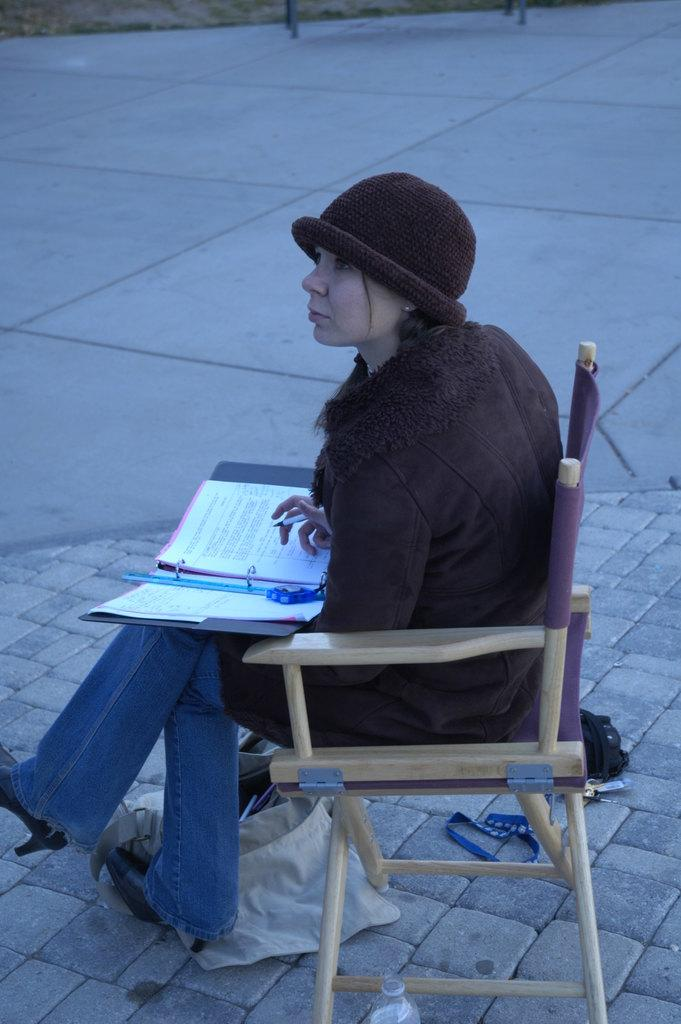What is the main subject of the image? The main subject of the image is a woman. What is the woman doing in the image? The woman is sitting in a chair in the image. What is the woman holding in the image? The woman is holding a file in the image. Can you see any stars in the image? There are no stars visible in the image. Is there a crook present in the image? There is no crook present in the image. 